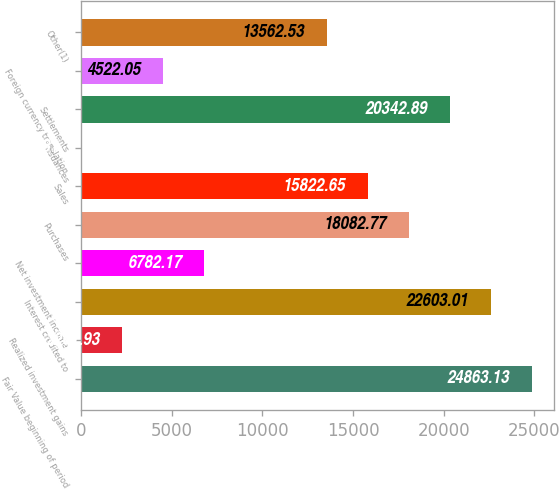Convert chart to OTSL. <chart><loc_0><loc_0><loc_500><loc_500><bar_chart><fcel>Fair Value beginning of period<fcel>Realized investment gains<fcel>Interest credited to<fcel>Net investment income<fcel>Purchases<fcel>Sales<fcel>Issuances<fcel>Settlements<fcel>Foreign currency translation<fcel>Other(1)<nl><fcel>24863.1<fcel>2261.93<fcel>22603<fcel>6782.17<fcel>18082.8<fcel>15822.6<fcel>1.81<fcel>20342.9<fcel>4522.05<fcel>13562.5<nl></chart> 